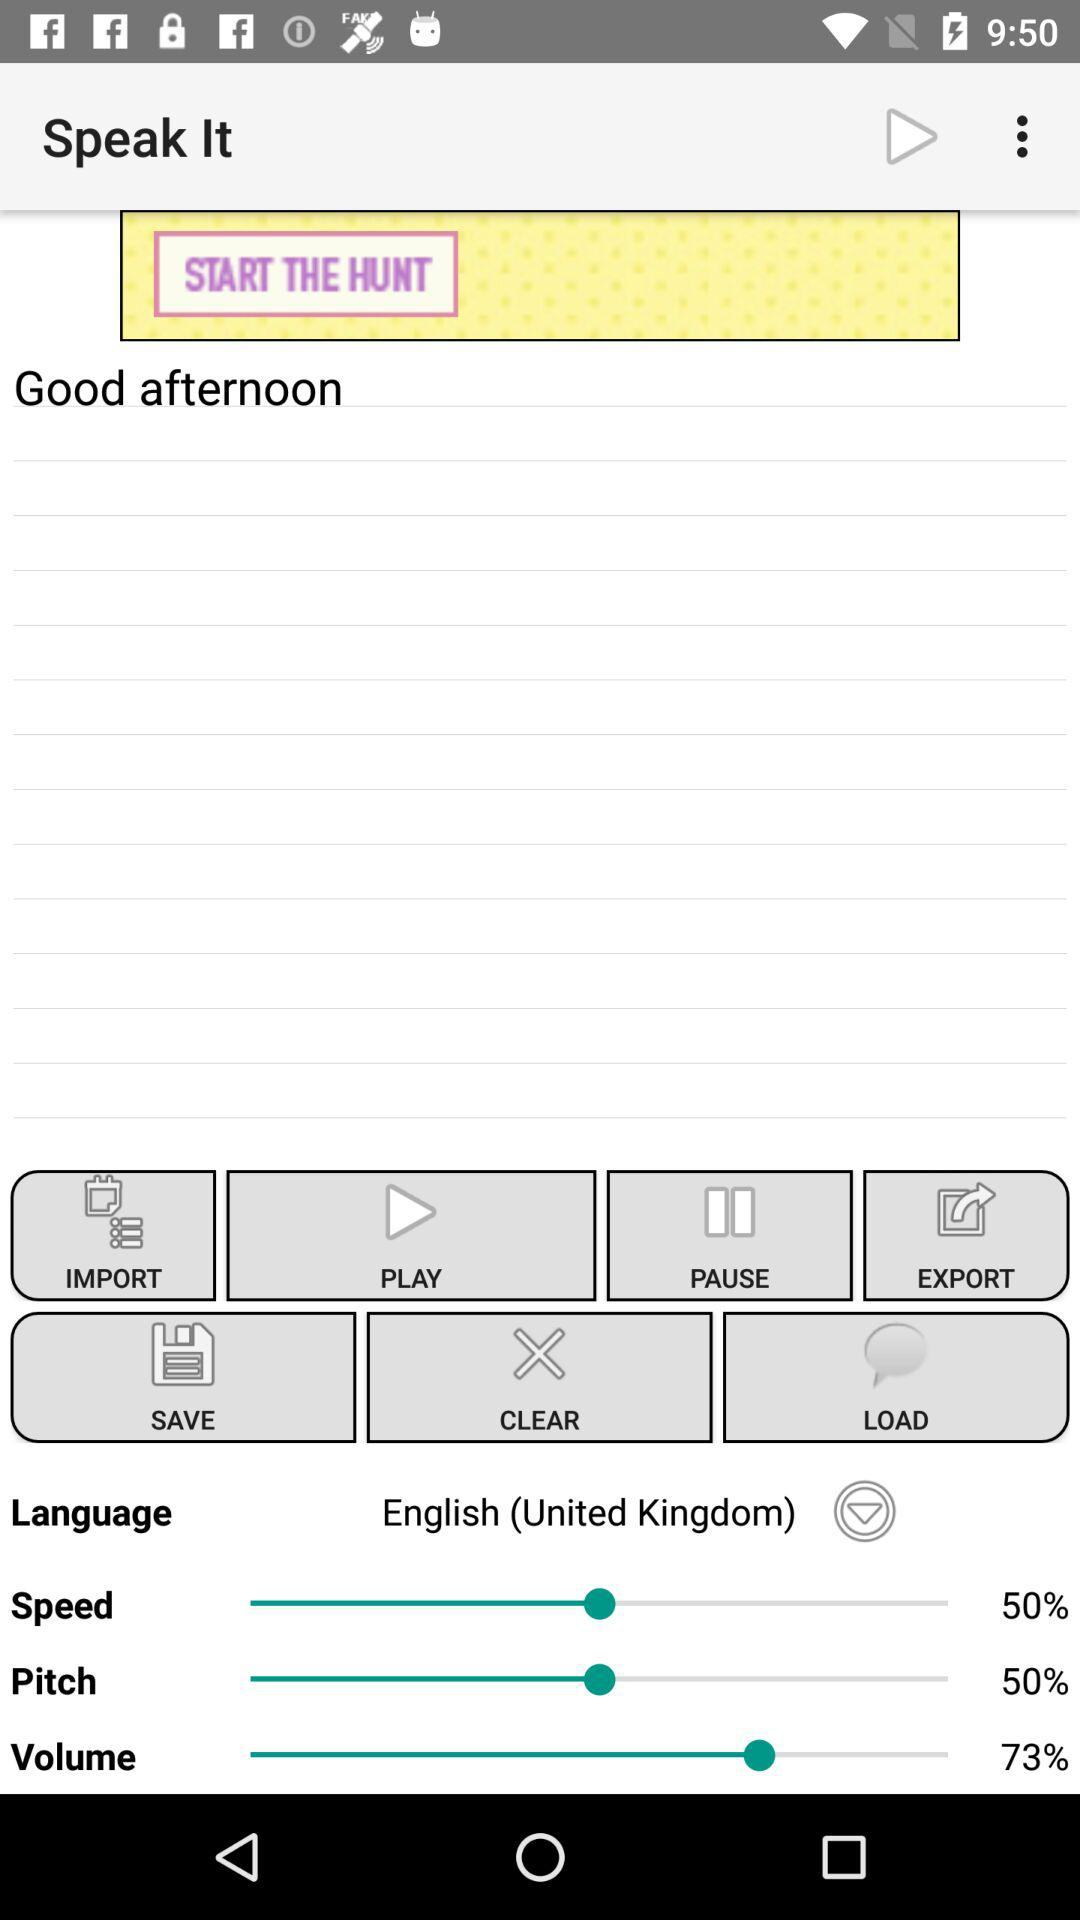What percentage is the "Pitch" option set to? The "Pitch" option is set to 50%. 